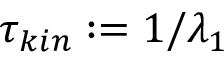Convert formula to latex. <formula><loc_0><loc_0><loc_500><loc_500>\tau _ { k i n } \colon = 1 / \lambda _ { 1 }</formula> 